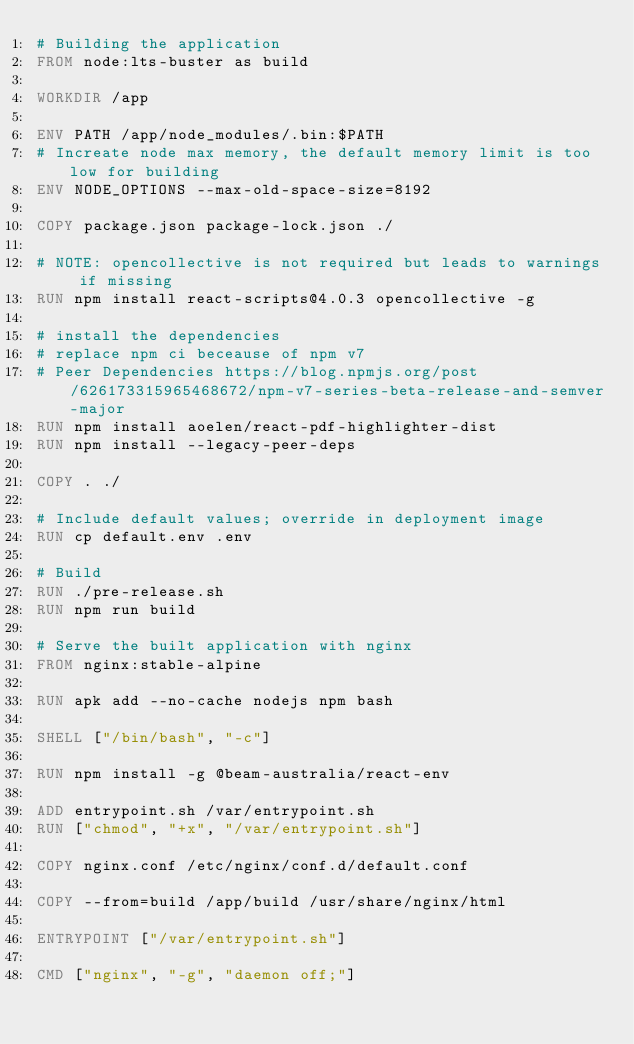Convert code to text. <code><loc_0><loc_0><loc_500><loc_500><_Dockerfile_># Building the application
FROM node:lts-buster as build

WORKDIR /app

ENV PATH /app/node_modules/.bin:$PATH
# Increate node max memory, the default memory limit is too low for building 
ENV NODE_OPTIONS --max-old-space-size=8192 

COPY package.json package-lock.json ./

# NOTE: opencollective is not required but leads to warnings if missing
RUN npm install react-scripts@4.0.3 opencollective -g

# install the dependencies
# replace npm ci beceause of npm v7   
# Peer Dependencies https://blog.npmjs.org/post/626173315965468672/npm-v7-series-beta-release-and-semver-major
RUN npm install aoelen/react-pdf-highlighter-dist
RUN npm install --legacy-peer-deps

COPY . ./

# Include default values; override in deployment image
RUN cp default.env .env

# Build
RUN ./pre-release.sh
RUN npm run build

# Serve the built application with nginx
FROM nginx:stable-alpine

RUN apk add --no-cache nodejs npm bash

SHELL ["/bin/bash", "-c"]

RUN npm install -g @beam-australia/react-env

ADD entrypoint.sh /var/entrypoint.sh
RUN ["chmod", "+x", "/var/entrypoint.sh"]

COPY nginx.conf /etc/nginx/conf.d/default.conf

COPY --from=build /app/build /usr/share/nginx/html

ENTRYPOINT ["/var/entrypoint.sh"]

CMD ["nginx", "-g", "daemon off;"]
</code> 